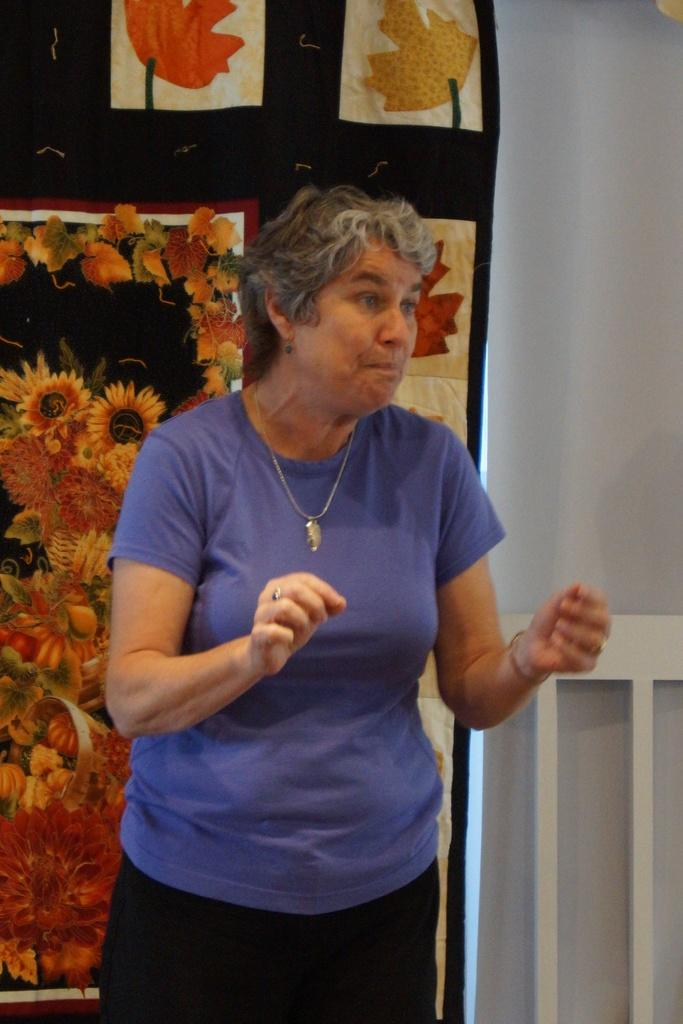Who is the main subject in the image? There is a woman in the image. What is the woman wearing? The woman is wearing a purple top. What is the woman's posture in the image? The woman is standing. What can be seen in the background of the image? There are arts on paper and a wall visible in the background of the image. What type of plastic material is being expanded by the woman in the image? There is no plastic material or expansion activity present in the image. 